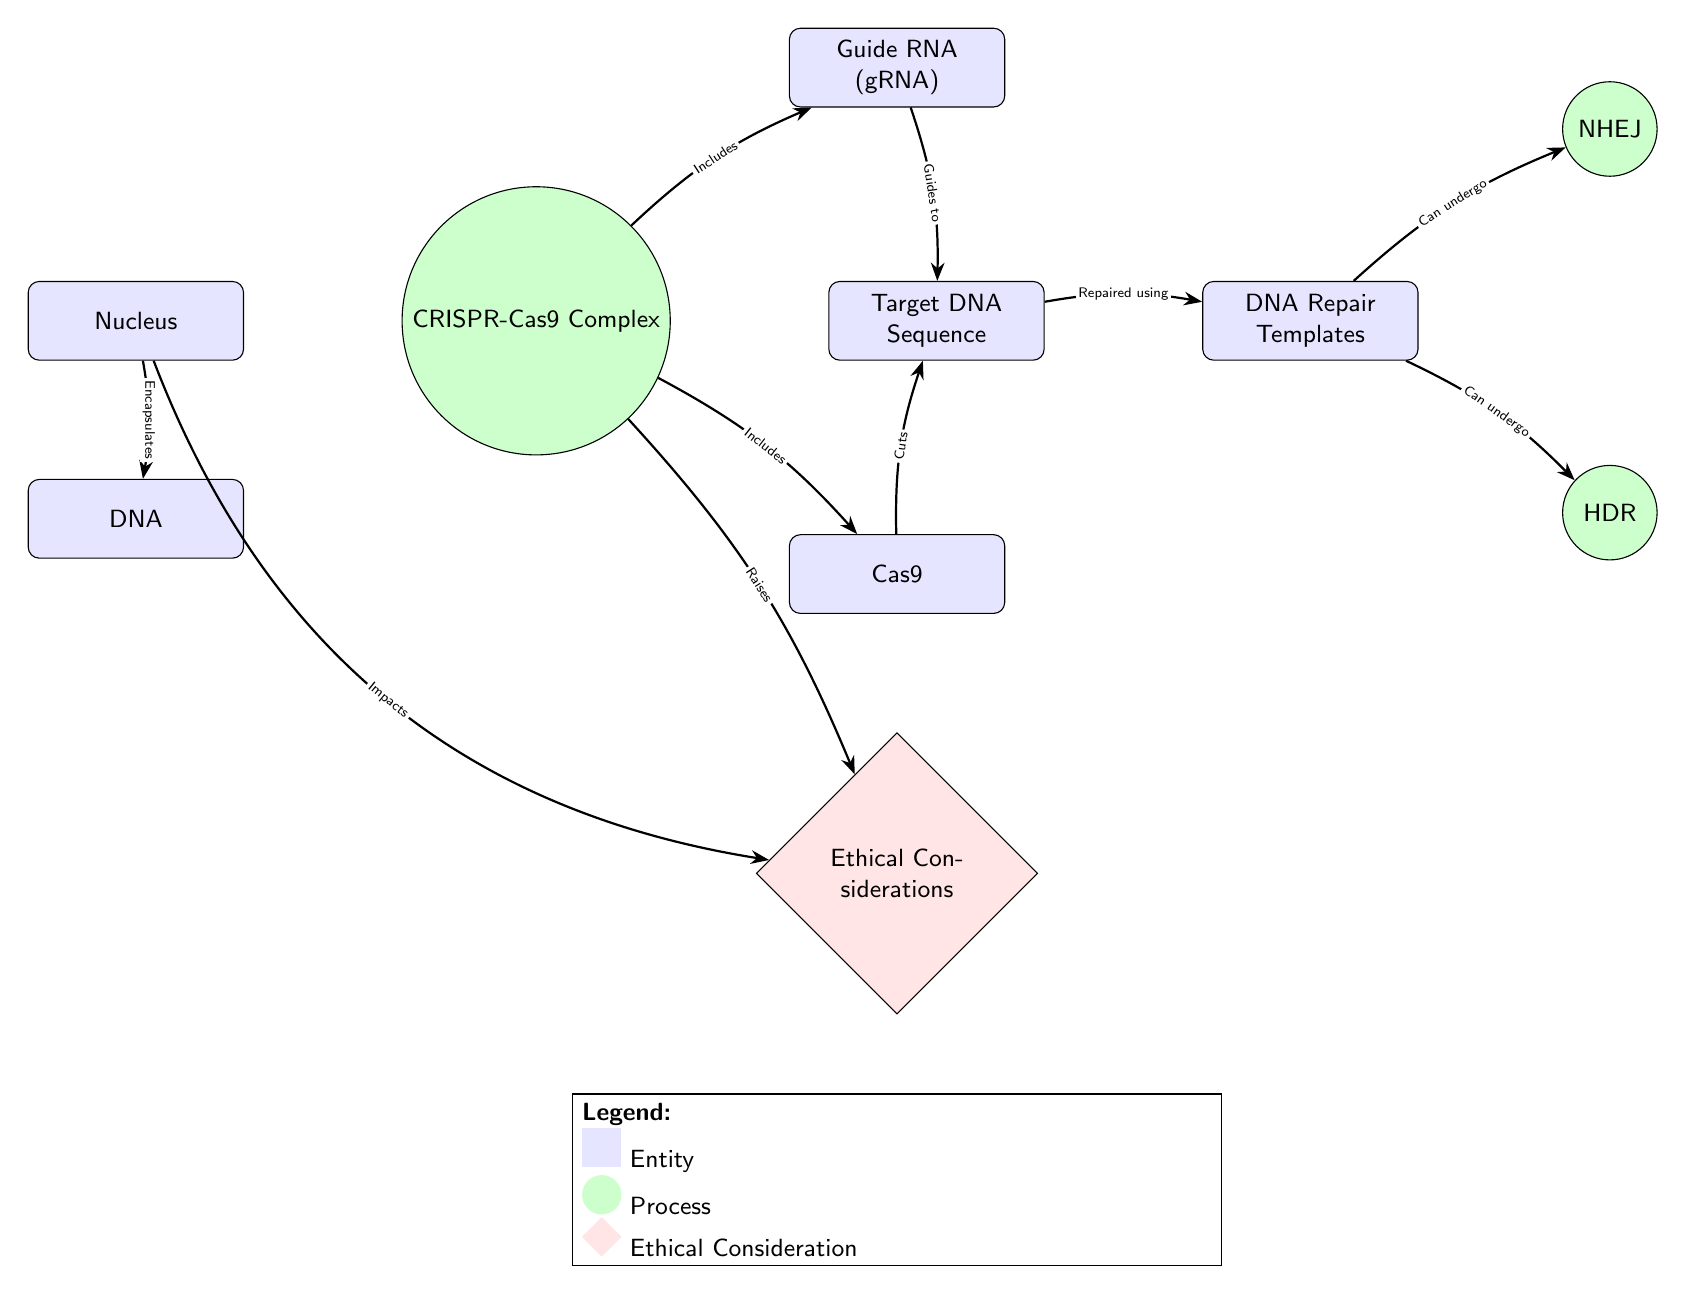What is the starting entity in the diagram? The diagram indicates that the flow begins from the "Nucleus," which encapsulates DNA. This is the first node that is visually represented.
Answer: Nucleus How many processes are represented in the diagram? Upon examining the diagram, two processes are identified: "NHEJ" and "HDR." These are the actions that follow the repair process in the DNA modification sequence.
Answer: 2 Which component guides the CRISPR-Cas9 Complex to the target DNA? The diagram shows that "Guide RNA (gRNA)" is directed to the "Target DNA Sequence." This labeling explicitly identifies the guiding function of gRNA.
Answer: Guide RNA What ethical consideration arises directly from the CRISPR-Cas9 mechanism? The connection from the "CRISPR-Cas9 Complex" to "Ethical Considerations" indicates that ethical questions and discussions are raised as a consequence of employing CRISPR technology.
Answer: Ethical Considerations How does the "Nucleus" impact the ethical considerations in the diagram? There is a direct connection indicating that the "Nucleus" has an impact on "Ethical Considerations." This reflects the moral implications of genetic changes originating from the cellular nucleus.
Answer: Impacts In what ways can the "DNA Repair Templates" be processed? The diagram indicates that the "DNA Repair Templates" can undergo either "NHEJ" or "HDR," both of which are processes associated with DNA repair. This suggests that these templates have multiple repair pathways.
Answer: NHEJ, HDR Which entity represents the target of the Cas9 cuts in the CRISPR process? The diagram specifies that the "Target DNA Sequence" represents the area where the Cas9 enzyme exerts its cutting action. The label clearly establishes this as the target entity in the process.
Answer: Target DNA Sequence What does "Cas9" do to the "Target DNA Sequence"? According to the diagram, the relationship shows that "Cas9" directly "Cuts" the "Target DNA Sequence," which is a vital part of the CRISPR-Cas9 function.
Answer: Cuts What type of ethical framework is suggested by the diagram regarding CRISPR technology? The ethical node labeled "Ethical Considerations" indicates that discussions and evaluations of CRISPR's moral implications are essential, signifying an ethical framework is necessary in this context.
Answer: Ethical framework 